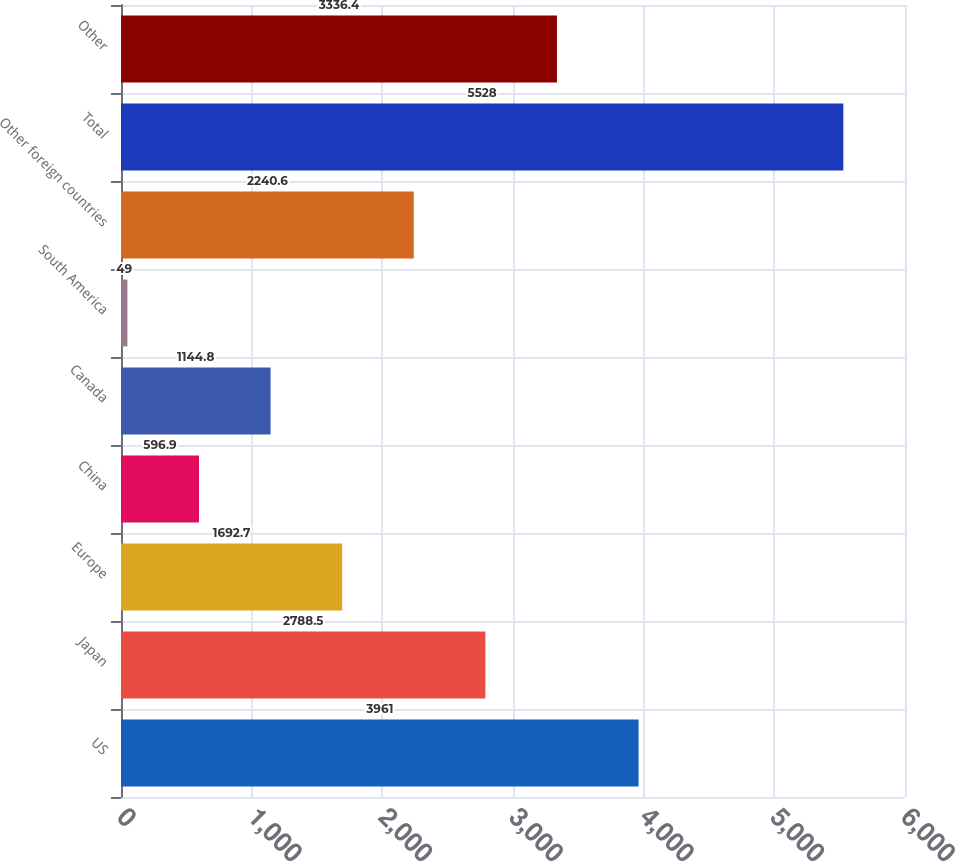Convert chart. <chart><loc_0><loc_0><loc_500><loc_500><bar_chart><fcel>US<fcel>Japan<fcel>Europe<fcel>China<fcel>Canada<fcel>South America<fcel>Other foreign countries<fcel>Total<fcel>Other<nl><fcel>3961<fcel>2788.5<fcel>1692.7<fcel>596.9<fcel>1144.8<fcel>49<fcel>2240.6<fcel>5528<fcel>3336.4<nl></chart> 